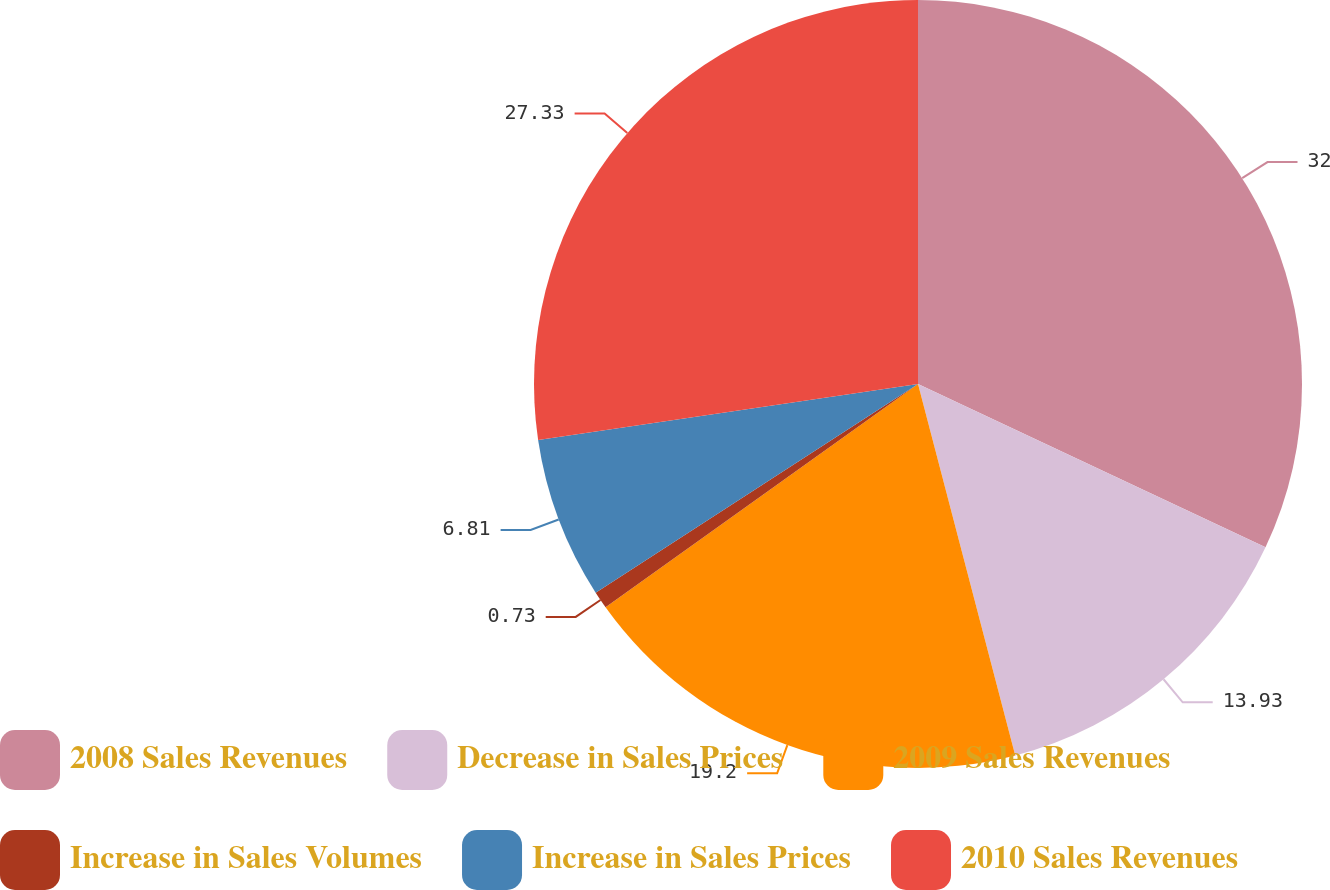<chart> <loc_0><loc_0><loc_500><loc_500><pie_chart><fcel>2008 Sales Revenues<fcel>Decrease in Sales Prices<fcel>2009 Sales Revenues<fcel>Increase in Sales Volumes<fcel>Increase in Sales Prices<fcel>2010 Sales Revenues<nl><fcel>31.99%<fcel>13.93%<fcel>19.2%<fcel>0.73%<fcel>6.81%<fcel>27.33%<nl></chart> 